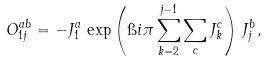<formula> <loc_0><loc_0><loc_500><loc_500>O _ { 1 j } ^ { a b } = - J _ { 1 } ^ { a } \, \exp \left ( \i i \pi \sum _ { k = 2 } ^ { j - 1 } \sum _ { c } J ^ { c } _ { k } \right ) \, J ^ { b } _ { j } ,</formula> 